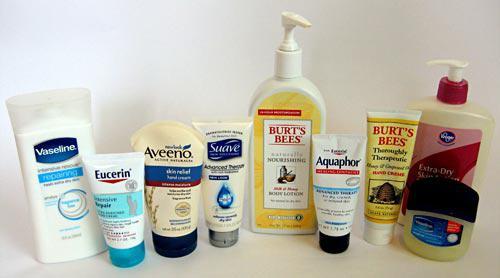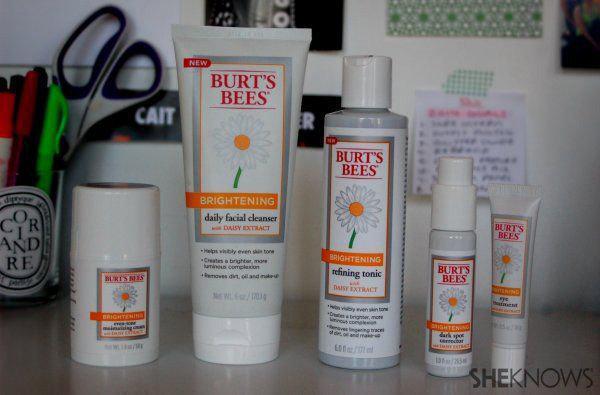The first image is the image on the left, the second image is the image on the right. For the images shown, is this caption "At least one image contains no more than one lotion product outside of its box." true? Answer yes or no. No. The first image is the image on the left, the second image is the image on the right. Assess this claim about the two images: "In each image, at least five different personal care products are arranged in a row so that all labels are showing.". Correct or not? Answer yes or no. Yes. 